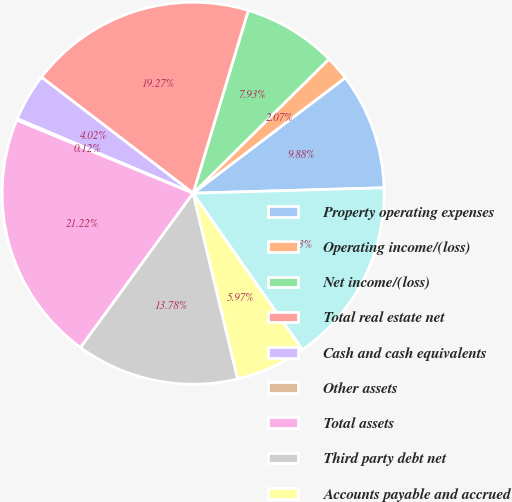<chart> <loc_0><loc_0><loc_500><loc_500><pie_chart><fcel>Property operating expenses<fcel>Operating income/(loss)<fcel>Net income/(loss)<fcel>Total real estate net<fcel>Cash and cash equivalents<fcel>Other assets<fcel>Total assets<fcel>Third party debt net<fcel>Accounts payable and accrued<fcel>Total liabilities<nl><fcel>9.88%<fcel>2.07%<fcel>7.93%<fcel>19.27%<fcel>4.02%<fcel>0.12%<fcel>21.22%<fcel>13.78%<fcel>5.97%<fcel>15.73%<nl></chart> 